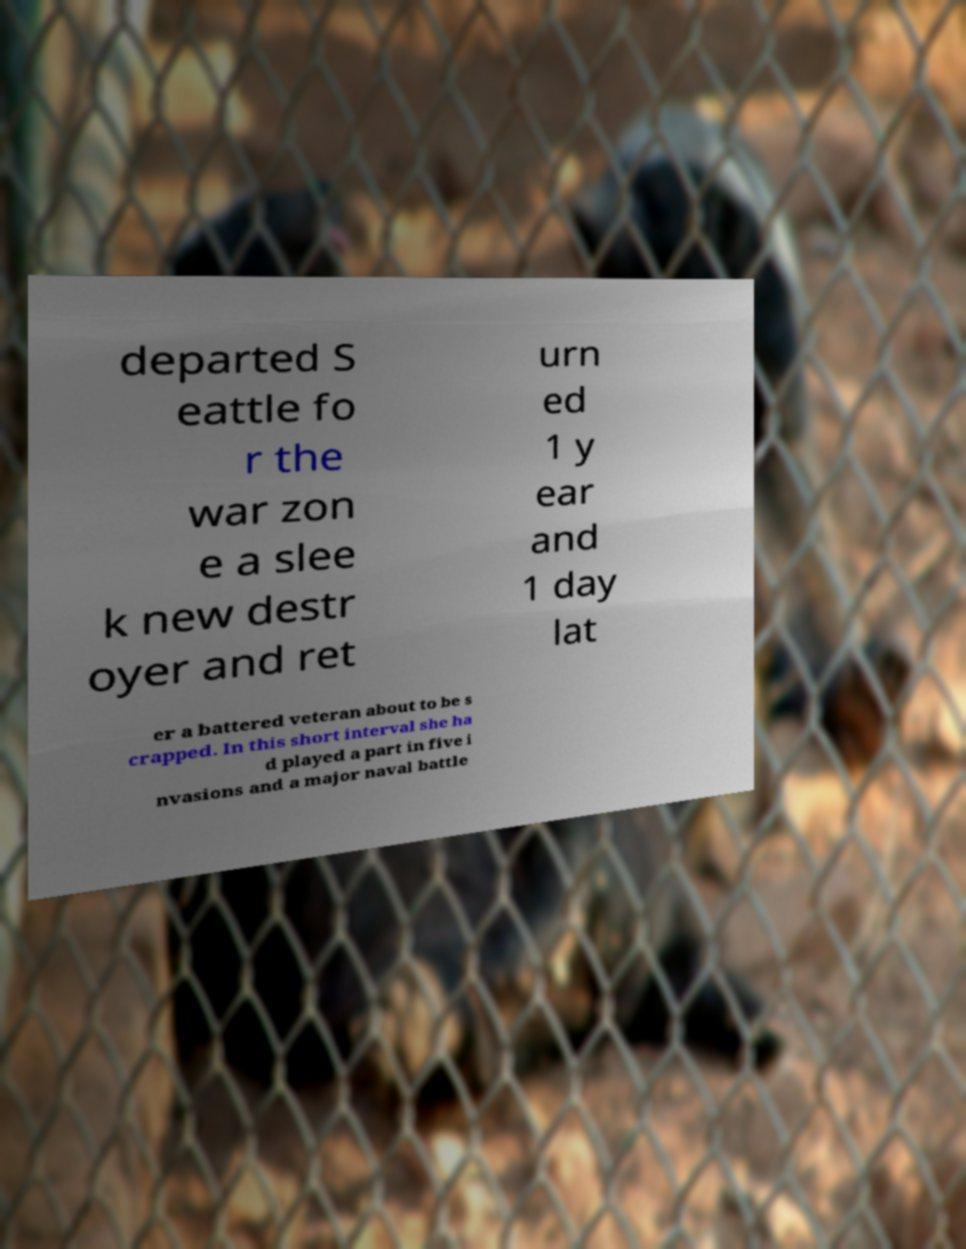Can you accurately transcribe the text from the provided image for me? departed S eattle fo r the war zon e a slee k new destr oyer and ret urn ed 1 y ear and 1 day lat er a battered veteran about to be s crapped. In this short interval she ha d played a part in five i nvasions and a major naval battle 